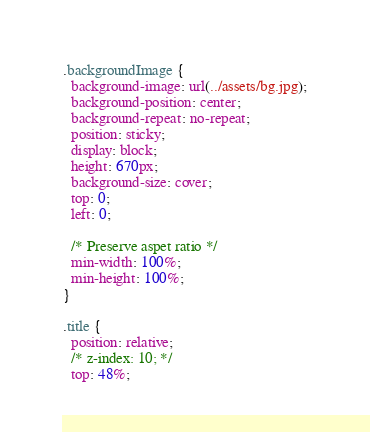Convert code to text. <code><loc_0><loc_0><loc_500><loc_500><_CSS_>.backgroundImage {
  background-image: url(../assets/bg.jpg);
  background-position: center;
  background-repeat: no-repeat;
  position: sticky;
  display: block;
  height: 670px;
  background-size: cover;
  top: 0;
  left: 0;

  /* Preserve aspet ratio */
  min-width: 100%;
  min-height: 100%;
}

.title {
  position: relative;
  /* z-index: 10; */
  top: 48%;</code> 